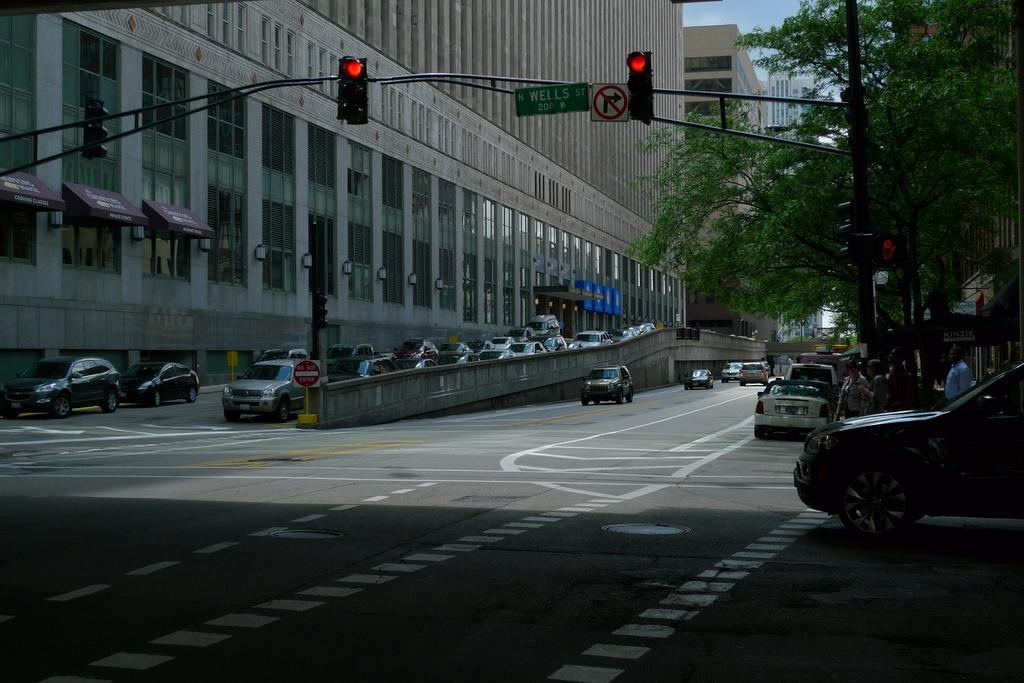Provide a one-sentence caption for the provided image. A black car is stopped at the intersection of North Wells Street. 